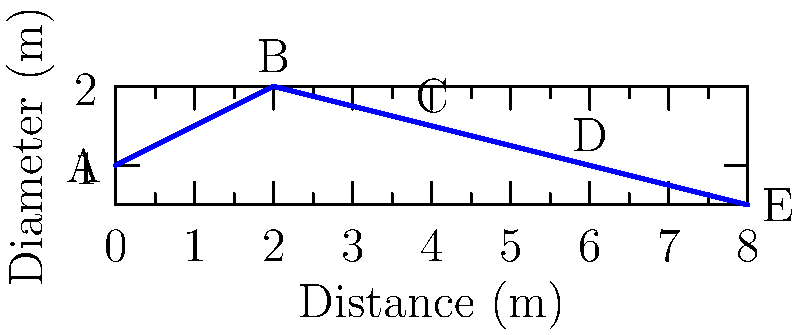Christine is working on a Mechanical Engineering project involving fluid flow through a pipe with varying cross-sectional areas. The graph shows the diameter of the pipe at different distances. If the flow rate is constant at 0.5 m³/s and the fluid density is 1000 kg/m³, calculate the pressure difference between points A and E. Assume the pipe is horizontal and neglect friction losses. Let's approach this step-by-step:

1) We'll use Bernoulli's equation: $$P_1 + \frac{1}{2}\rho v_1^2 + \rho gh_1 = P_2 + \frac{1}{2}\rho v_2^2 + \rho gh_2$$

2) Since the pipe is horizontal, $h_1 = h_2$, so these terms cancel out.

3) We need to find velocities at A and E. We can use the continuity equation: $$Q = A_1v_1 = A_2v_2$$

4) At A: $D_A = 1$ m, $A_A = \pi(0.5)^2 = 0.785$ m²
   $v_A = Q/A_A = 0.5/0.785 = 0.637$ m/s

5) At E: $D_E = 0.5$ m, $A_E = \pi(0.25)^2 = 0.196$ m²
   $v_E = Q/A_E = 0.5/0.196 = 2.55$ m/s

6) Now we can use Bernoulli's equation:
   $$P_A + \frac{1}{2}\rho v_A^2 = P_E + \frac{1}{2}\rho v_E^2$$

7) Rearranging: $$P_A - P_E = \frac{1}{2}\rho(v_E^2 - v_A^2)$$

8) Plugging in values:
   $$P_A - P_E = \frac{1}{2}(1000)(2.55^2 - 0.637^2) = 3086.5$$ Pa

Therefore, the pressure difference between A and E is 3086.5 Pa, with pressure at A being higher.
Answer: 3086.5 Pa 